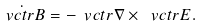Convert formula to latex. <formula><loc_0><loc_0><loc_500><loc_500>\dot { \ v c t r { B } } = - \ v c t r { \nabla } \times \ v c t r { E } .</formula> 